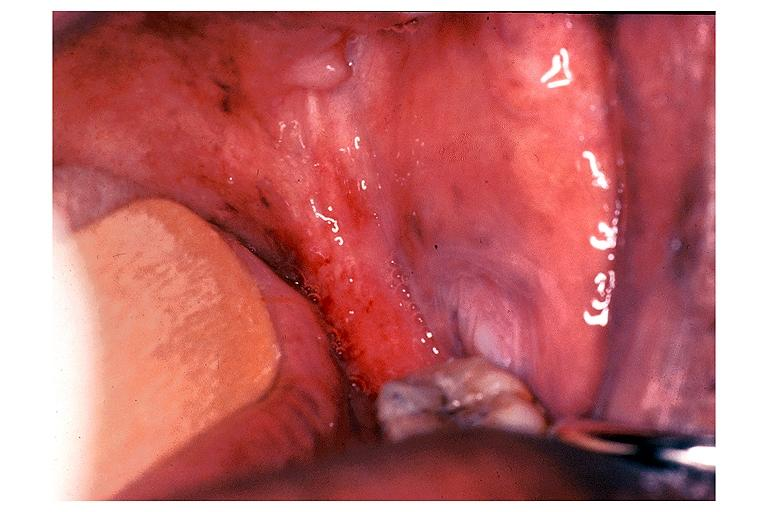what does this image show?
Answer the question using a single word or phrase. Erythroplakia 